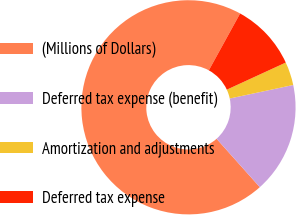<chart> <loc_0><loc_0><loc_500><loc_500><pie_chart><fcel>(Millions of Dollars)<fcel>Deferred tax expense (benefit)<fcel>Amortization and adjustments<fcel>Deferred tax expense<nl><fcel>69.62%<fcel>16.74%<fcel>3.52%<fcel>10.13%<nl></chart> 